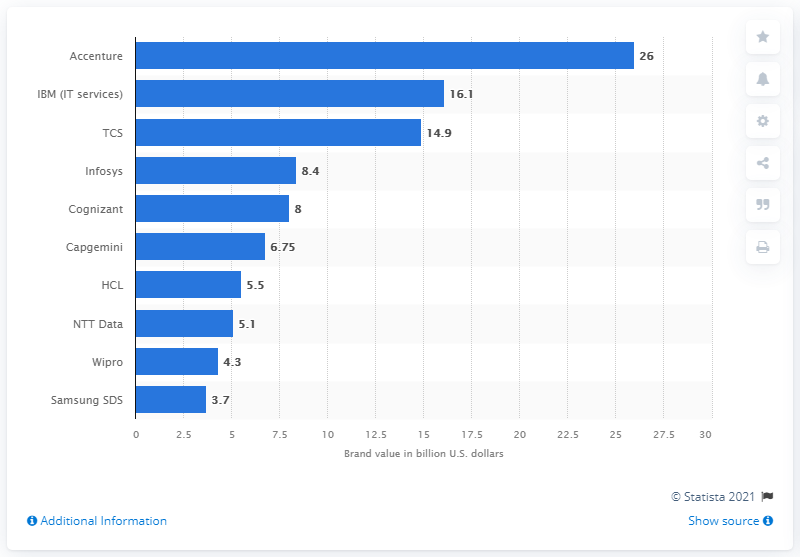Specify some key components in this picture. Accenture's brand value is approximately 26 billion dollars. 